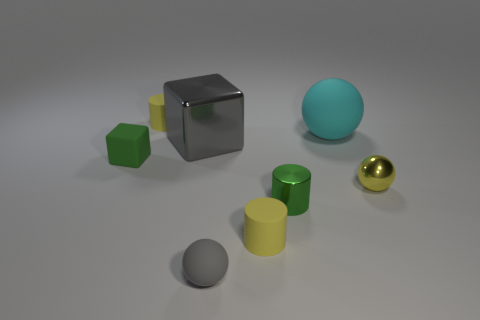Subtract all big balls. How many balls are left? 2 Subtract 2 balls. How many balls are left? 1 Subtract all red balls. Subtract all gray cubes. How many balls are left? 3 Subtract all green cylinders. How many cylinders are left? 2 Subtract 0 red blocks. How many objects are left? 8 Subtract all cylinders. How many objects are left? 5 Subtract all blue balls. How many yellow cylinders are left? 2 Subtract all cyan spheres. Subtract all metallic balls. How many objects are left? 6 Add 4 rubber things. How many rubber things are left? 9 Add 3 gray matte balls. How many gray matte balls exist? 4 